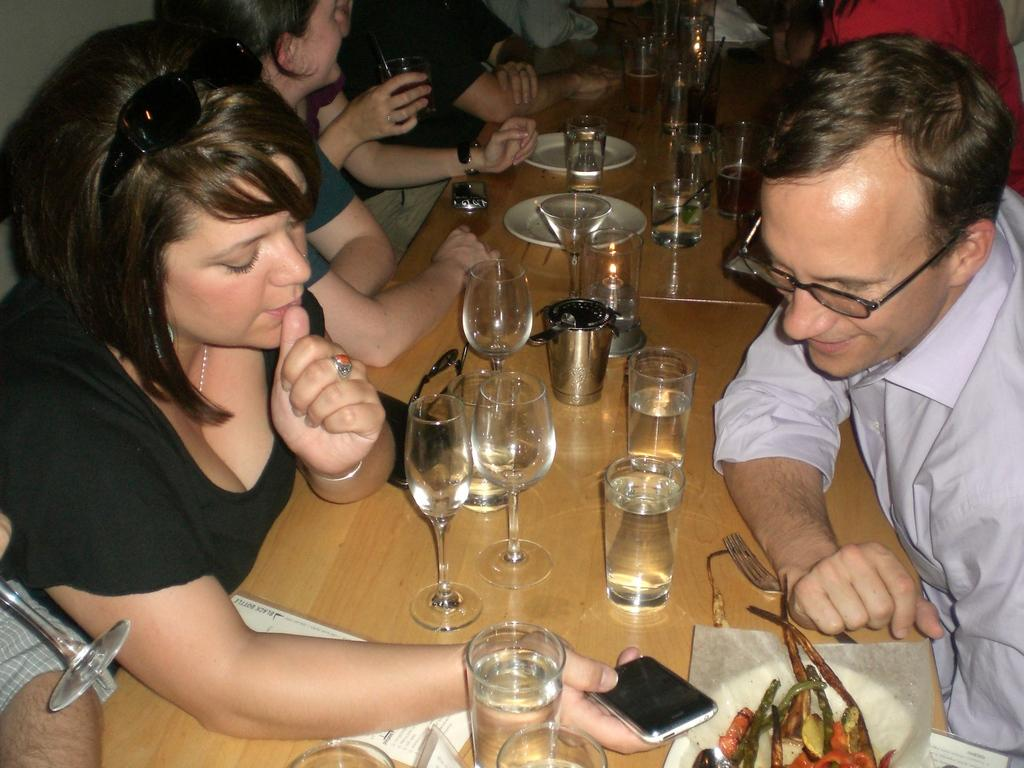What are the people in the image doing? There is a group of people sitting in the image. What objects are on the table in the image? There are glasses and plates on the table. What can be found on the plates on the table? There is a food item on a plate on the table. What type of string is being used to tie the people together in the image? There is no string or any indication of people being tied together in the image. 